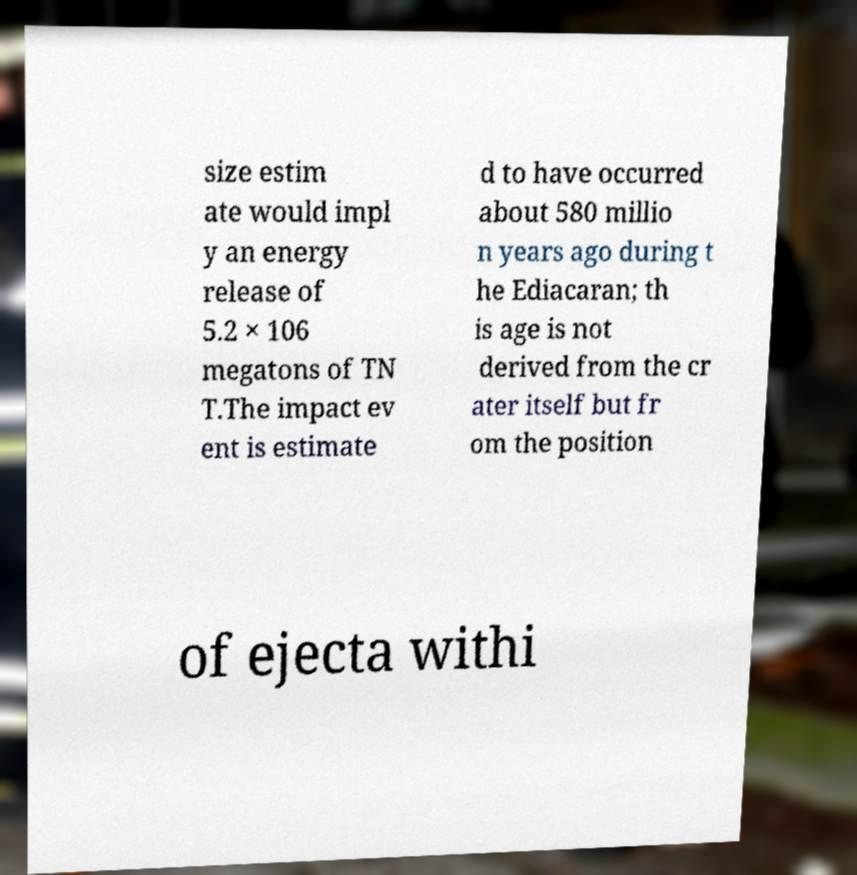Please identify and transcribe the text found in this image. size estim ate would impl y an energy release of 5.2 × 106 megatons of TN T.The impact ev ent is estimate d to have occurred about 580 millio n years ago during t he Ediacaran; th is age is not derived from the cr ater itself but fr om the position of ejecta withi 